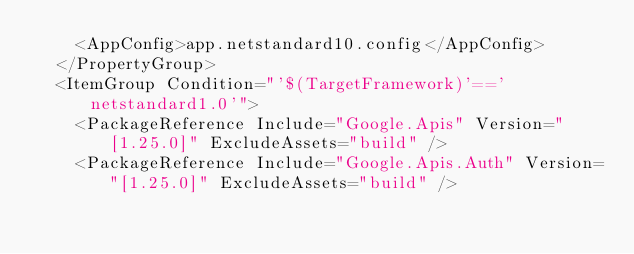Convert code to text. <code><loc_0><loc_0><loc_500><loc_500><_XML_>    <AppConfig>app.netstandard10.config</AppConfig>
  </PropertyGroup>
  <ItemGroup Condition="'$(TargetFramework)'=='netstandard1.0'">
    <PackageReference Include="Google.Apis" Version="[1.25.0]" ExcludeAssets="build" />
    <PackageReference Include="Google.Apis.Auth" Version="[1.25.0]" ExcludeAssets="build" /></code> 